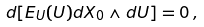Convert formula to latex. <formula><loc_0><loc_0><loc_500><loc_500>d [ E _ { U } ( U ) d X _ { 0 } \wedge d U ] = 0 \, ,</formula> 